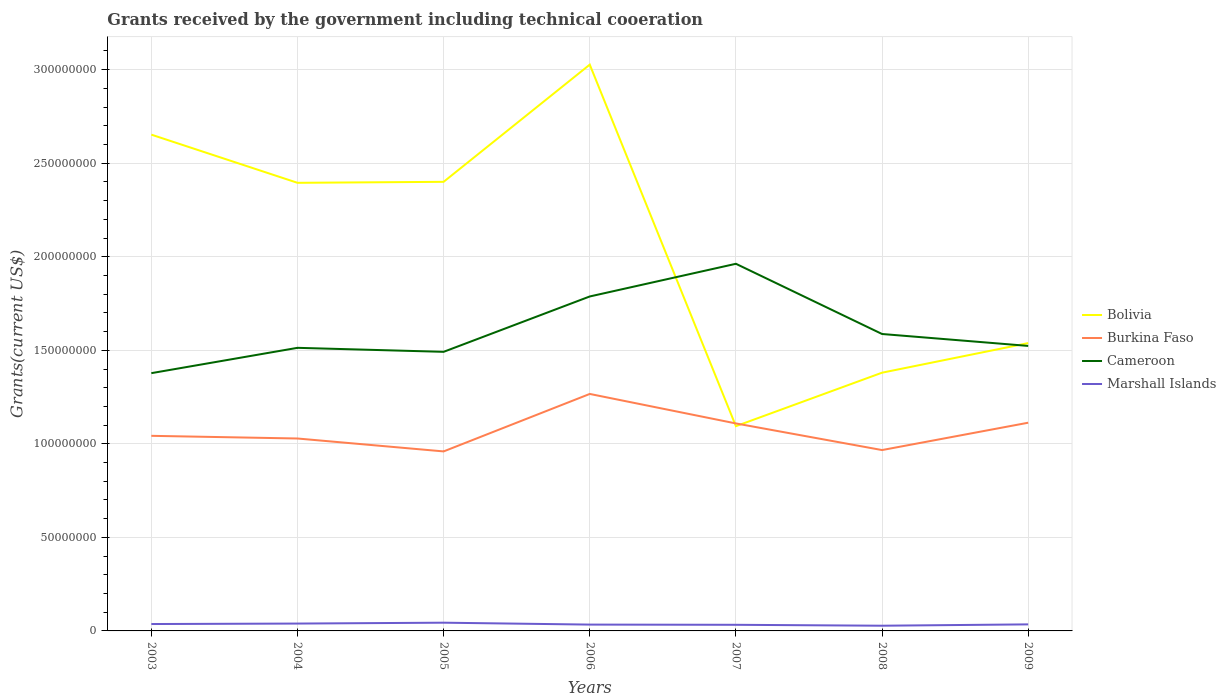How many different coloured lines are there?
Your answer should be compact. 4. Across all years, what is the maximum total grants received by the government in Cameroon?
Your response must be concise. 1.38e+08. What is the total total grants received by the government in Bolivia in the graph?
Give a very brief answer. 1.30e+08. What is the difference between the highest and the second highest total grants received by the government in Marshall Islands?
Offer a terse response. 1.62e+06. How many legend labels are there?
Make the answer very short. 4. How are the legend labels stacked?
Provide a short and direct response. Vertical. What is the title of the graph?
Your answer should be compact. Grants received by the government including technical cooeration. Does "Cayman Islands" appear as one of the legend labels in the graph?
Offer a very short reply. No. What is the label or title of the X-axis?
Your answer should be very brief. Years. What is the label or title of the Y-axis?
Your response must be concise. Grants(current US$). What is the Grants(current US$) of Bolivia in 2003?
Your answer should be compact. 2.65e+08. What is the Grants(current US$) of Burkina Faso in 2003?
Ensure brevity in your answer.  1.04e+08. What is the Grants(current US$) in Cameroon in 2003?
Offer a very short reply. 1.38e+08. What is the Grants(current US$) of Marshall Islands in 2003?
Make the answer very short. 3.68e+06. What is the Grants(current US$) of Bolivia in 2004?
Provide a short and direct response. 2.40e+08. What is the Grants(current US$) in Burkina Faso in 2004?
Offer a very short reply. 1.03e+08. What is the Grants(current US$) in Cameroon in 2004?
Your response must be concise. 1.51e+08. What is the Grants(current US$) in Marshall Islands in 2004?
Provide a succinct answer. 3.93e+06. What is the Grants(current US$) in Bolivia in 2005?
Provide a succinct answer. 2.40e+08. What is the Grants(current US$) in Burkina Faso in 2005?
Give a very brief answer. 9.60e+07. What is the Grants(current US$) of Cameroon in 2005?
Your response must be concise. 1.49e+08. What is the Grants(current US$) of Marshall Islands in 2005?
Your answer should be very brief. 4.40e+06. What is the Grants(current US$) of Bolivia in 2006?
Make the answer very short. 3.03e+08. What is the Grants(current US$) of Burkina Faso in 2006?
Offer a terse response. 1.27e+08. What is the Grants(current US$) in Cameroon in 2006?
Ensure brevity in your answer.  1.79e+08. What is the Grants(current US$) of Marshall Islands in 2006?
Your answer should be very brief. 3.38e+06. What is the Grants(current US$) in Bolivia in 2007?
Provide a succinct answer. 1.09e+08. What is the Grants(current US$) in Burkina Faso in 2007?
Provide a short and direct response. 1.11e+08. What is the Grants(current US$) in Cameroon in 2007?
Your answer should be compact. 1.96e+08. What is the Grants(current US$) in Marshall Islands in 2007?
Provide a short and direct response. 3.27e+06. What is the Grants(current US$) of Bolivia in 2008?
Keep it short and to the point. 1.38e+08. What is the Grants(current US$) in Burkina Faso in 2008?
Give a very brief answer. 9.67e+07. What is the Grants(current US$) in Cameroon in 2008?
Ensure brevity in your answer.  1.59e+08. What is the Grants(current US$) of Marshall Islands in 2008?
Provide a short and direct response. 2.78e+06. What is the Grants(current US$) in Bolivia in 2009?
Provide a succinct answer. 1.54e+08. What is the Grants(current US$) in Burkina Faso in 2009?
Offer a terse response. 1.11e+08. What is the Grants(current US$) in Cameroon in 2009?
Make the answer very short. 1.52e+08. What is the Grants(current US$) in Marshall Islands in 2009?
Your answer should be compact. 3.50e+06. Across all years, what is the maximum Grants(current US$) in Bolivia?
Provide a succinct answer. 3.03e+08. Across all years, what is the maximum Grants(current US$) in Burkina Faso?
Provide a short and direct response. 1.27e+08. Across all years, what is the maximum Grants(current US$) in Cameroon?
Make the answer very short. 1.96e+08. Across all years, what is the maximum Grants(current US$) of Marshall Islands?
Give a very brief answer. 4.40e+06. Across all years, what is the minimum Grants(current US$) in Bolivia?
Offer a terse response. 1.09e+08. Across all years, what is the minimum Grants(current US$) in Burkina Faso?
Your response must be concise. 9.60e+07. Across all years, what is the minimum Grants(current US$) of Cameroon?
Provide a succinct answer. 1.38e+08. Across all years, what is the minimum Grants(current US$) of Marshall Islands?
Your answer should be compact. 2.78e+06. What is the total Grants(current US$) of Bolivia in the graph?
Keep it short and to the point. 1.45e+09. What is the total Grants(current US$) of Burkina Faso in the graph?
Provide a short and direct response. 7.49e+08. What is the total Grants(current US$) in Cameroon in the graph?
Keep it short and to the point. 1.12e+09. What is the total Grants(current US$) in Marshall Islands in the graph?
Offer a terse response. 2.49e+07. What is the difference between the Grants(current US$) of Bolivia in 2003 and that in 2004?
Offer a very short reply. 2.58e+07. What is the difference between the Grants(current US$) in Burkina Faso in 2003 and that in 2004?
Provide a short and direct response. 1.43e+06. What is the difference between the Grants(current US$) of Cameroon in 2003 and that in 2004?
Ensure brevity in your answer.  -1.35e+07. What is the difference between the Grants(current US$) in Bolivia in 2003 and that in 2005?
Offer a very short reply. 2.52e+07. What is the difference between the Grants(current US$) in Burkina Faso in 2003 and that in 2005?
Provide a short and direct response. 8.33e+06. What is the difference between the Grants(current US$) in Cameroon in 2003 and that in 2005?
Your answer should be compact. -1.14e+07. What is the difference between the Grants(current US$) of Marshall Islands in 2003 and that in 2005?
Your answer should be very brief. -7.20e+05. What is the difference between the Grants(current US$) in Bolivia in 2003 and that in 2006?
Your response must be concise. -3.74e+07. What is the difference between the Grants(current US$) in Burkina Faso in 2003 and that in 2006?
Keep it short and to the point. -2.24e+07. What is the difference between the Grants(current US$) of Cameroon in 2003 and that in 2006?
Make the answer very short. -4.10e+07. What is the difference between the Grants(current US$) in Marshall Islands in 2003 and that in 2006?
Your answer should be very brief. 3.00e+05. What is the difference between the Grants(current US$) of Bolivia in 2003 and that in 2007?
Provide a succinct answer. 1.56e+08. What is the difference between the Grants(current US$) of Burkina Faso in 2003 and that in 2007?
Ensure brevity in your answer.  -6.62e+06. What is the difference between the Grants(current US$) of Cameroon in 2003 and that in 2007?
Provide a succinct answer. -5.85e+07. What is the difference between the Grants(current US$) of Bolivia in 2003 and that in 2008?
Provide a succinct answer. 1.27e+08. What is the difference between the Grants(current US$) in Burkina Faso in 2003 and that in 2008?
Provide a succinct answer. 7.61e+06. What is the difference between the Grants(current US$) in Cameroon in 2003 and that in 2008?
Your answer should be very brief. -2.09e+07. What is the difference between the Grants(current US$) in Marshall Islands in 2003 and that in 2008?
Make the answer very short. 9.00e+05. What is the difference between the Grants(current US$) of Bolivia in 2003 and that in 2009?
Ensure brevity in your answer.  1.11e+08. What is the difference between the Grants(current US$) in Burkina Faso in 2003 and that in 2009?
Offer a very short reply. -7.01e+06. What is the difference between the Grants(current US$) of Cameroon in 2003 and that in 2009?
Offer a terse response. -1.46e+07. What is the difference between the Grants(current US$) of Marshall Islands in 2003 and that in 2009?
Ensure brevity in your answer.  1.80e+05. What is the difference between the Grants(current US$) in Bolivia in 2004 and that in 2005?
Ensure brevity in your answer.  -5.30e+05. What is the difference between the Grants(current US$) of Burkina Faso in 2004 and that in 2005?
Ensure brevity in your answer.  6.90e+06. What is the difference between the Grants(current US$) in Cameroon in 2004 and that in 2005?
Offer a terse response. 2.14e+06. What is the difference between the Grants(current US$) of Marshall Islands in 2004 and that in 2005?
Give a very brief answer. -4.70e+05. What is the difference between the Grants(current US$) of Bolivia in 2004 and that in 2006?
Provide a short and direct response. -6.32e+07. What is the difference between the Grants(current US$) of Burkina Faso in 2004 and that in 2006?
Give a very brief answer. -2.38e+07. What is the difference between the Grants(current US$) of Cameroon in 2004 and that in 2006?
Provide a succinct answer. -2.74e+07. What is the difference between the Grants(current US$) in Marshall Islands in 2004 and that in 2006?
Make the answer very short. 5.50e+05. What is the difference between the Grants(current US$) in Bolivia in 2004 and that in 2007?
Keep it short and to the point. 1.30e+08. What is the difference between the Grants(current US$) in Burkina Faso in 2004 and that in 2007?
Keep it short and to the point. -8.05e+06. What is the difference between the Grants(current US$) of Cameroon in 2004 and that in 2007?
Offer a very short reply. -4.49e+07. What is the difference between the Grants(current US$) in Marshall Islands in 2004 and that in 2007?
Provide a short and direct response. 6.60e+05. What is the difference between the Grants(current US$) in Bolivia in 2004 and that in 2008?
Your answer should be compact. 1.01e+08. What is the difference between the Grants(current US$) of Burkina Faso in 2004 and that in 2008?
Your answer should be very brief. 6.18e+06. What is the difference between the Grants(current US$) of Cameroon in 2004 and that in 2008?
Offer a very short reply. -7.39e+06. What is the difference between the Grants(current US$) of Marshall Islands in 2004 and that in 2008?
Offer a terse response. 1.15e+06. What is the difference between the Grants(current US$) of Bolivia in 2004 and that in 2009?
Ensure brevity in your answer.  8.57e+07. What is the difference between the Grants(current US$) of Burkina Faso in 2004 and that in 2009?
Offer a terse response. -8.44e+06. What is the difference between the Grants(current US$) in Cameroon in 2004 and that in 2009?
Keep it short and to the point. -1.02e+06. What is the difference between the Grants(current US$) in Marshall Islands in 2004 and that in 2009?
Make the answer very short. 4.30e+05. What is the difference between the Grants(current US$) of Bolivia in 2005 and that in 2006?
Your answer should be very brief. -6.26e+07. What is the difference between the Grants(current US$) of Burkina Faso in 2005 and that in 2006?
Provide a succinct answer. -3.07e+07. What is the difference between the Grants(current US$) in Cameroon in 2005 and that in 2006?
Your response must be concise. -2.96e+07. What is the difference between the Grants(current US$) in Marshall Islands in 2005 and that in 2006?
Give a very brief answer. 1.02e+06. What is the difference between the Grants(current US$) of Bolivia in 2005 and that in 2007?
Ensure brevity in your answer.  1.31e+08. What is the difference between the Grants(current US$) in Burkina Faso in 2005 and that in 2007?
Give a very brief answer. -1.50e+07. What is the difference between the Grants(current US$) in Cameroon in 2005 and that in 2007?
Your answer should be very brief. -4.71e+07. What is the difference between the Grants(current US$) of Marshall Islands in 2005 and that in 2007?
Your response must be concise. 1.13e+06. What is the difference between the Grants(current US$) in Bolivia in 2005 and that in 2008?
Provide a succinct answer. 1.02e+08. What is the difference between the Grants(current US$) in Burkina Faso in 2005 and that in 2008?
Give a very brief answer. -7.20e+05. What is the difference between the Grants(current US$) in Cameroon in 2005 and that in 2008?
Offer a terse response. -9.53e+06. What is the difference between the Grants(current US$) in Marshall Islands in 2005 and that in 2008?
Make the answer very short. 1.62e+06. What is the difference between the Grants(current US$) of Bolivia in 2005 and that in 2009?
Keep it short and to the point. 8.62e+07. What is the difference between the Grants(current US$) in Burkina Faso in 2005 and that in 2009?
Your answer should be compact. -1.53e+07. What is the difference between the Grants(current US$) of Cameroon in 2005 and that in 2009?
Offer a very short reply. -3.16e+06. What is the difference between the Grants(current US$) of Bolivia in 2006 and that in 2007?
Provide a short and direct response. 1.93e+08. What is the difference between the Grants(current US$) of Burkina Faso in 2006 and that in 2007?
Provide a succinct answer. 1.58e+07. What is the difference between the Grants(current US$) of Cameroon in 2006 and that in 2007?
Keep it short and to the point. -1.75e+07. What is the difference between the Grants(current US$) of Marshall Islands in 2006 and that in 2007?
Offer a very short reply. 1.10e+05. What is the difference between the Grants(current US$) of Bolivia in 2006 and that in 2008?
Your response must be concise. 1.65e+08. What is the difference between the Grants(current US$) of Burkina Faso in 2006 and that in 2008?
Your answer should be very brief. 3.00e+07. What is the difference between the Grants(current US$) of Cameroon in 2006 and that in 2008?
Give a very brief answer. 2.01e+07. What is the difference between the Grants(current US$) in Bolivia in 2006 and that in 2009?
Your answer should be very brief. 1.49e+08. What is the difference between the Grants(current US$) of Burkina Faso in 2006 and that in 2009?
Provide a succinct answer. 1.54e+07. What is the difference between the Grants(current US$) of Cameroon in 2006 and that in 2009?
Keep it short and to the point. 2.64e+07. What is the difference between the Grants(current US$) of Bolivia in 2007 and that in 2008?
Ensure brevity in your answer.  -2.86e+07. What is the difference between the Grants(current US$) in Burkina Faso in 2007 and that in 2008?
Provide a succinct answer. 1.42e+07. What is the difference between the Grants(current US$) of Cameroon in 2007 and that in 2008?
Provide a succinct answer. 3.75e+07. What is the difference between the Grants(current US$) in Bolivia in 2007 and that in 2009?
Keep it short and to the point. -4.44e+07. What is the difference between the Grants(current US$) of Burkina Faso in 2007 and that in 2009?
Keep it short and to the point. -3.90e+05. What is the difference between the Grants(current US$) of Cameroon in 2007 and that in 2009?
Provide a short and direct response. 4.39e+07. What is the difference between the Grants(current US$) in Bolivia in 2008 and that in 2009?
Offer a very short reply. -1.58e+07. What is the difference between the Grants(current US$) of Burkina Faso in 2008 and that in 2009?
Make the answer very short. -1.46e+07. What is the difference between the Grants(current US$) of Cameroon in 2008 and that in 2009?
Your answer should be compact. 6.37e+06. What is the difference between the Grants(current US$) in Marshall Islands in 2008 and that in 2009?
Keep it short and to the point. -7.20e+05. What is the difference between the Grants(current US$) of Bolivia in 2003 and the Grants(current US$) of Burkina Faso in 2004?
Make the answer very short. 1.62e+08. What is the difference between the Grants(current US$) in Bolivia in 2003 and the Grants(current US$) in Cameroon in 2004?
Make the answer very short. 1.14e+08. What is the difference between the Grants(current US$) of Bolivia in 2003 and the Grants(current US$) of Marshall Islands in 2004?
Your response must be concise. 2.61e+08. What is the difference between the Grants(current US$) of Burkina Faso in 2003 and the Grants(current US$) of Cameroon in 2004?
Give a very brief answer. -4.70e+07. What is the difference between the Grants(current US$) in Burkina Faso in 2003 and the Grants(current US$) in Marshall Islands in 2004?
Provide a short and direct response. 1.00e+08. What is the difference between the Grants(current US$) of Cameroon in 2003 and the Grants(current US$) of Marshall Islands in 2004?
Your response must be concise. 1.34e+08. What is the difference between the Grants(current US$) of Bolivia in 2003 and the Grants(current US$) of Burkina Faso in 2005?
Keep it short and to the point. 1.69e+08. What is the difference between the Grants(current US$) in Bolivia in 2003 and the Grants(current US$) in Cameroon in 2005?
Keep it short and to the point. 1.16e+08. What is the difference between the Grants(current US$) in Bolivia in 2003 and the Grants(current US$) in Marshall Islands in 2005?
Keep it short and to the point. 2.61e+08. What is the difference between the Grants(current US$) of Burkina Faso in 2003 and the Grants(current US$) of Cameroon in 2005?
Give a very brief answer. -4.49e+07. What is the difference between the Grants(current US$) in Burkina Faso in 2003 and the Grants(current US$) in Marshall Islands in 2005?
Provide a short and direct response. 9.99e+07. What is the difference between the Grants(current US$) of Cameroon in 2003 and the Grants(current US$) of Marshall Islands in 2005?
Give a very brief answer. 1.33e+08. What is the difference between the Grants(current US$) of Bolivia in 2003 and the Grants(current US$) of Burkina Faso in 2006?
Keep it short and to the point. 1.39e+08. What is the difference between the Grants(current US$) in Bolivia in 2003 and the Grants(current US$) in Cameroon in 2006?
Give a very brief answer. 8.65e+07. What is the difference between the Grants(current US$) of Bolivia in 2003 and the Grants(current US$) of Marshall Islands in 2006?
Make the answer very short. 2.62e+08. What is the difference between the Grants(current US$) of Burkina Faso in 2003 and the Grants(current US$) of Cameroon in 2006?
Make the answer very short. -7.45e+07. What is the difference between the Grants(current US$) in Burkina Faso in 2003 and the Grants(current US$) in Marshall Islands in 2006?
Your answer should be very brief. 1.01e+08. What is the difference between the Grants(current US$) of Cameroon in 2003 and the Grants(current US$) of Marshall Islands in 2006?
Offer a terse response. 1.34e+08. What is the difference between the Grants(current US$) in Bolivia in 2003 and the Grants(current US$) in Burkina Faso in 2007?
Provide a short and direct response. 1.54e+08. What is the difference between the Grants(current US$) of Bolivia in 2003 and the Grants(current US$) of Cameroon in 2007?
Provide a succinct answer. 6.90e+07. What is the difference between the Grants(current US$) in Bolivia in 2003 and the Grants(current US$) in Marshall Islands in 2007?
Keep it short and to the point. 2.62e+08. What is the difference between the Grants(current US$) in Burkina Faso in 2003 and the Grants(current US$) in Cameroon in 2007?
Offer a very short reply. -9.20e+07. What is the difference between the Grants(current US$) of Burkina Faso in 2003 and the Grants(current US$) of Marshall Islands in 2007?
Your response must be concise. 1.01e+08. What is the difference between the Grants(current US$) in Cameroon in 2003 and the Grants(current US$) in Marshall Islands in 2007?
Your response must be concise. 1.35e+08. What is the difference between the Grants(current US$) of Bolivia in 2003 and the Grants(current US$) of Burkina Faso in 2008?
Make the answer very short. 1.69e+08. What is the difference between the Grants(current US$) in Bolivia in 2003 and the Grants(current US$) in Cameroon in 2008?
Keep it short and to the point. 1.07e+08. What is the difference between the Grants(current US$) in Bolivia in 2003 and the Grants(current US$) in Marshall Islands in 2008?
Give a very brief answer. 2.62e+08. What is the difference between the Grants(current US$) in Burkina Faso in 2003 and the Grants(current US$) in Cameroon in 2008?
Your answer should be compact. -5.44e+07. What is the difference between the Grants(current US$) in Burkina Faso in 2003 and the Grants(current US$) in Marshall Islands in 2008?
Make the answer very short. 1.02e+08. What is the difference between the Grants(current US$) of Cameroon in 2003 and the Grants(current US$) of Marshall Islands in 2008?
Your answer should be compact. 1.35e+08. What is the difference between the Grants(current US$) of Bolivia in 2003 and the Grants(current US$) of Burkina Faso in 2009?
Offer a terse response. 1.54e+08. What is the difference between the Grants(current US$) in Bolivia in 2003 and the Grants(current US$) in Cameroon in 2009?
Offer a very short reply. 1.13e+08. What is the difference between the Grants(current US$) of Bolivia in 2003 and the Grants(current US$) of Marshall Islands in 2009?
Your response must be concise. 2.62e+08. What is the difference between the Grants(current US$) in Burkina Faso in 2003 and the Grants(current US$) in Cameroon in 2009?
Provide a short and direct response. -4.81e+07. What is the difference between the Grants(current US$) of Burkina Faso in 2003 and the Grants(current US$) of Marshall Islands in 2009?
Ensure brevity in your answer.  1.01e+08. What is the difference between the Grants(current US$) of Cameroon in 2003 and the Grants(current US$) of Marshall Islands in 2009?
Offer a terse response. 1.34e+08. What is the difference between the Grants(current US$) of Bolivia in 2004 and the Grants(current US$) of Burkina Faso in 2005?
Your response must be concise. 1.44e+08. What is the difference between the Grants(current US$) in Bolivia in 2004 and the Grants(current US$) in Cameroon in 2005?
Give a very brief answer. 9.03e+07. What is the difference between the Grants(current US$) in Bolivia in 2004 and the Grants(current US$) in Marshall Islands in 2005?
Your response must be concise. 2.35e+08. What is the difference between the Grants(current US$) of Burkina Faso in 2004 and the Grants(current US$) of Cameroon in 2005?
Keep it short and to the point. -4.63e+07. What is the difference between the Grants(current US$) of Burkina Faso in 2004 and the Grants(current US$) of Marshall Islands in 2005?
Give a very brief answer. 9.84e+07. What is the difference between the Grants(current US$) in Cameroon in 2004 and the Grants(current US$) in Marshall Islands in 2005?
Offer a terse response. 1.47e+08. What is the difference between the Grants(current US$) in Bolivia in 2004 and the Grants(current US$) in Burkina Faso in 2006?
Your answer should be compact. 1.13e+08. What is the difference between the Grants(current US$) in Bolivia in 2004 and the Grants(current US$) in Cameroon in 2006?
Give a very brief answer. 6.08e+07. What is the difference between the Grants(current US$) in Bolivia in 2004 and the Grants(current US$) in Marshall Islands in 2006?
Provide a succinct answer. 2.36e+08. What is the difference between the Grants(current US$) of Burkina Faso in 2004 and the Grants(current US$) of Cameroon in 2006?
Keep it short and to the point. -7.59e+07. What is the difference between the Grants(current US$) of Burkina Faso in 2004 and the Grants(current US$) of Marshall Islands in 2006?
Give a very brief answer. 9.95e+07. What is the difference between the Grants(current US$) of Cameroon in 2004 and the Grants(current US$) of Marshall Islands in 2006?
Keep it short and to the point. 1.48e+08. What is the difference between the Grants(current US$) in Bolivia in 2004 and the Grants(current US$) in Burkina Faso in 2007?
Offer a terse response. 1.29e+08. What is the difference between the Grants(current US$) in Bolivia in 2004 and the Grants(current US$) in Cameroon in 2007?
Your response must be concise. 4.33e+07. What is the difference between the Grants(current US$) in Bolivia in 2004 and the Grants(current US$) in Marshall Islands in 2007?
Offer a terse response. 2.36e+08. What is the difference between the Grants(current US$) of Burkina Faso in 2004 and the Grants(current US$) of Cameroon in 2007?
Offer a very short reply. -9.34e+07. What is the difference between the Grants(current US$) in Burkina Faso in 2004 and the Grants(current US$) in Marshall Islands in 2007?
Your response must be concise. 9.96e+07. What is the difference between the Grants(current US$) of Cameroon in 2004 and the Grants(current US$) of Marshall Islands in 2007?
Make the answer very short. 1.48e+08. What is the difference between the Grants(current US$) in Bolivia in 2004 and the Grants(current US$) in Burkina Faso in 2008?
Offer a terse response. 1.43e+08. What is the difference between the Grants(current US$) in Bolivia in 2004 and the Grants(current US$) in Cameroon in 2008?
Provide a short and direct response. 8.08e+07. What is the difference between the Grants(current US$) in Bolivia in 2004 and the Grants(current US$) in Marshall Islands in 2008?
Your answer should be compact. 2.37e+08. What is the difference between the Grants(current US$) in Burkina Faso in 2004 and the Grants(current US$) in Cameroon in 2008?
Make the answer very short. -5.59e+07. What is the difference between the Grants(current US$) of Burkina Faso in 2004 and the Grants(current US$) of Marshall Islands in 2008?
Your answer should be very brief. 1.00e+08. What is the difference between the Grants(current US$) in Cameroon in 2004 and the Grants(current US$) in Marshall Islands in 2008?
Give a very brief answer. 1.49e+08. What is the difference between the Grants(current US$) in Bolivia in 2004 and the Grants(current US$) in Burkina Faso in 2009?
Keep it short and to the point. 1.28e+08. What is the difference between the Grants(current US$) of Bolivia in 2004 and the Grants(current US$) of Cameroon in 2009?
Make the answer very short. 8.72e+07. What is the difference between the Grants(current US$) of Bolivia in 2004 and the Grants(current US$) of Marshall Islands in 2009?
Give a very brief answer. 2.36e+08. What is the difference between the Grants(current US$) of Burkina Faso in 2004 and the Grants(current US$) of Cameroon in 2009?
Offer a very short reply. -4.95e+07. What is the difference between the Grants(current US$) of Burkina Faso in 2004 and the Grants(current US$) of Marshall Islands in 2009?
Give a very brief answer. 9.94e+07. What is the difference between the Grants(current US$) of Cameroon in 2004 and the Grants(current US$) of Marshall Islands in 2009?
Offer a very short reply. 1.48e+08. What is the difference between the Grants(current US$) in Bolivia in 2005 and the Grants(current US$) in Burkina Faso in 2006?
Give a very brief answer. 1.13e+08. What is the difference between the Grants(current US$) in Bolivia in 2005 and the Grants(current US$) in Cameroon in 2006?
Keep it short and to the point. 6.13e+07. What is the difference between the Grants(current US$) in Bolivia in 2005 and the Grants(current US$) in Marshall Islands in 2006?
Your answer should be very brief. 2.37e+08. What is the difference between the Grants(current US$) of Burkina Faso in 2005 and the Grants(current US$) of Cameroon in 2006?
Provide a short and direct response. -8.28e+07. What is the difference between the Grants(current US$) of Burkina Faso in 2005 and the Grants(current US$) of Marshall Islands in 2006?
Your answer should be compact. 9.26e+07. What is the difference between the Grants(current US$) in Cameroon in 2005 and the Grants(current US$) in Marshall Islands in 2006?
Your response must be concise. 1.46e+08. What is the difference between the Grants(current US$) in Bolivia in 2005 and the Grants(current US$) in Burkina Faso in 2007?
Offer a very short reply. 1.29e+08. What is the difference between the Grants(current US$) in Bolivia in 2005 and the Grants(current US$) in Cameroon in 2007?
Keep it short and to the point. 4.38e+07. What is the difference between the Grants(current US$) in Bolivia in 2005 and the Grants(current US$) in Marshall Islands in 2007?
Your response must be concise. 2.37e+08. What is the difference between the Grants(current US$) in Burkina Faso in 2005 and the Grants(current US$) in Cameroon in 2007?
Keep it short and to the point. -1.00e+08. What is the difference between the Grants(current US$) of Burkina Faso in 2005 and the Grants(current US$) of Marshall Islands in 2007?
Offer a very short reply. 9.27e+07. What is the difference between the Grants(current US$) of Cameroon in 2005 and the Grants(current US$) of Marshall Islands in 2007?
Make the answer very short. 1.46e+08. What is the difference between the Grants(current US$) in Bolivia in 2005 and the Grants(current US$) in Burkina Faso in 2008?
Make the answer very short. 1.43e+08. What is the difference between the Grants(current US$) of Bolivia in 2005 and the Grants(current US$) of Cameroon in 2008?
Ensure brevity in your answer.  8.13e+07. What is the difference between the Grants(current US$) in Bolivia in 2005 and the Grants(current US$) in Marshall Islands in 2008?
Offer a very short reply. 2.37e+08. What is the difference between the Grants(current US$) of Burkina Faso in 2005 and the Grants(current US$) of Cameroon in 2008?
Your answer should be compact. -6.28e+07. What is the difference between the Grants(current US$) of Burkina Faso in 2005 and the Grants(current US$) of Marshall Islands in 2008?
Give a very brief answer. 9.32e+07. What is the difference between the Grants(current US$) of Cameroon in 2005 and the Grants(current US$) of Marshall Islands in 2008?
Provide a succinct answer. 1.46e+08. What is the difference between the Grants(current US$) in Bolivia in 2005 and the Grants(current US$) in Burkina Faso in 2009?
Offer a terse response. 1.29e+08. What is the difference between the Grants(current US$) of Bolivia in 2005 and the Grants(current US$) of Cameroon in 2009?
Ensure brevity in your answer.  8.77e+07. What is the difference between the Grants(current US$) in Bolivia in 2005 and the Grants(current US$) in Marshall Islands in 2009?
Provide a succinct answer. 2.37e+08. What is the difference between the Grants(current US$) in Burkina Faso in 2005 and the Grants(current US$) in Cameroon in 2009?
Your response must be concise. -5.64e+07. What is the difference between the Grants(current US$) in Burkina Faso in 2005 and the Grants(current US$) in Marshall Islands in 2009?
Ensure brevity in your answer.  9.24e+07. What is the difference between the Grants(current US$) of Cameroon in 2005 and the Grants(current US$) of Marshall Islands in 2009?
Provide a short and direct response. 1.46e+08. What is the difference between the Grants(current US$) of Bolivia in 2006 and the Grants(current US$) of Burkina Faso in 2007?
Give a very brief answer. 1.92e+08. What is the difference between the Grants(current US$) in Bolivia in 2006 and the Grants(current US$) in Cameroon in 2007?
Your answer should be very brief. 1.06e+08. What is the difference between the Grants(current US$) in Bolivia in 2006 and the Grants(current US$) in Marshall Islands in 2007?
Give a very brief answer. 2.99e+08. What is the difference between the Grants(current US$) of Burkina Faso in 2006 and the Grants(current US$) of Cameroon in 2007?
Provide a succinct answer. -6.96e+07. What is the difference between the Grants(current US$) in Burkina Faso in 2006 and the Grants(current US$) in Marshall Islands in 2007?
Make the answer very short. 1.23e+08. What is the difference between the Grants(current US$) of Cameroon in 2006 and the Grants(current US$) of Marshall Islands in 2007?
Offer a very short reply. 1.76e+08. What is the difference between the Grants(current US$) in Bolivia in 2006 and the Grants(current US$) in Burkina Faso in 2008?
Provide a succinct answer. 2.06e+08. What is the difference between the Grants(current US$) of Bolivia in 2006 and the Grants(current US$) of Cameroon in 2008?
Offer a terse response. 1.44e+08. What is the difference between the Grants(current US$) of Bolivia in 2006 and the Grants(current US$) of Marshall Islands in 2008?
Ensure brevity in your answer.  3.00e+08. What is the difference between the Grants(current US$) in Burkina Faso in 2006 and the Grants(current US$) in Cameroon in 2008?
Your answer should be very brief. -3.20e+07. What is the difference between the Grants(current US$) of Burkina Faso in 2006 and the Grants(current US$) of Marshall Islands in 2008?
Your response must be concise. 1.24e+08. What is the difference between the Grants(current US$) in Cameroon in 2006 and the Grants(current US$) in Marshall Islands in 2008?
Ensure brevity in your answer.  1.76e+08. What is the difference between the Grants(current US$) of Bolivia in 2006 and the Grants(current US$) of Burkina Faso in 2009?
Your response must be concise. 1.91e+08. What is the difference between the Grants(current US$) of Bolivia in 2006 and the Grants(current US$) of Cameroon in 2009?
Offer a very short reply. 1.50e+08. What is the difference between the Grants(current US$) in Bolivia in 2006 and the Grants(current US$) in Marshall Islands in 2009?
Your answer should be very brief. 2.99e+08. What is the difference between the Grants(current US$) of Burkina Faso in 2006 and the Grants(current US$) of Cameroon in 2009?
Keep it short and to the point. -2.57e+07. What is the difference between the Grants(current US$) in Burkina Faso in 2006 and the Grants(current US$) in Marshall Islands in 2009?
Give a very brief answer. 1.23e+08. What is the difference between the Grants(current US$) of Cameroon in 2006 and the Grants(current US$) of Marshall Islands in 2009?
Give a very brief answer. 1.75e+08. What is the difference between the Grants(current US$) of Bolivia in 2007 and the Grants(current US$) of Burkina Faso in 2008?
Make the answer very short. 1.28e+07. What is the difference between the Grants(current US$) in Bolivia in 2007 and the Grants(current US$) in Cameroon in 2008?
Provide a short and direct response. -4.93e+07. What is the difference between the Grants(current US$) of Bolivia in 2007 and the Grants(current US$) of Marshall Islands in 2008?
Offer a very short reply. 1.07e+08. What is the difference between the Grants(current US$) in Burkina Faso in 2007 and the Grants(current US$) in Cameroon in 2008?
Your answer should be very brief. -4.78e+07. What is the difference between the Grants(current US$) of Burkina Faso in 2007 and the Grants(current US$) of Marshall Islands in 2008?
Ensure brevity in your answer.  1.08e+08. What is the difference between the Grants(current US$) in Cameroon in 2007 and the Grants(current US$) in Marshall Islands in 2008?
Your response must be concise. 1.93e+08. What is the difference between the Grants(current US$) in Bolivia in 2007 and the Grants(current US$) in Burkina Faso in 2009?
Provide a succinct answer. -1.85e+06. What is the difference between the Grants(current US$) of Bolivia in 2007 and the Grants(current US$) of Cameroon in 2009?
Offer a terse response. -4.29e+07. What is the difference between the Grants(current US$) of Bolivia in 2007 and the Grants(current US$) of Marshall Islands in 2009?
Give a very brief answer. 1.06e+08. What is the difference between the Grants(current US$) of Burkina Faso in 2007 and the Grants(current US$) of Cameroon in 2009?
Offer a very short reply. -4.14e+07. What is the difference between the Grants(current US$) of Burkina Faso in 2007 and the Grants(current US$) of Marshall Islands in 2009?
Offer a terse response. 1.07e+08. What is the difference between the Grants(current US$) of Cameroon in 2007 and the Grants(current US$) of Marshall Islands in 2009?
Your response must be concise. 1.93e+08. What is the difference between the Grants(current US$) of Bolivia in 2008 and the Grants(current US$) of Burkina Faso in 2009?
Make the answer very short. 2.67e+07. What is the difference between the Grants(current US$) in Bolivia in 2008 and the Grants(current US$) in Cameroon in 2009?
Keep it short and to the point. -1.43e+07. What is the difference between the Grants(current US$) in Bolivia in 2008 and the Grants(current US$) in Marshall Islands in 2009?
Ensure brevity in your answer.  1.35e+08. What is the difference between the Grants(current US$) of Burkina Faso in 2008 and the Grants(current US$) of Cameroon in 2009?
Provide a succinct answer. -5.57e+07. What is the difference between the Grants(current US$) of Burkina Faso in 2008 and the Grants(current US$) of Marshall Islands in 2009?
Offer a very short reply. 9.32e+07. What is the difference between the Grants(current US$) of Cameroon in 2008 and the Grants(current US$) of Marshall Islands in 2009?
Give a very brief answer. 1.55e+08. What is the average Grants(current US$) of Bolivia per year?
Your answer should be very brief. 2.07e+08. What is the average Grants(current US$) of Burkina Faso per year?
Offer a very short reply. 1.07e+08. What is the average Grants(current US$) in Cameroon per year?
Make the answer very short. 1.61e+08. What is the average Grants(current US$) in Marshall Islands per year?
Your response must be concise. 3.56e+06. In the year 2003, what is the difference between the Grants(current US$) in Bolivia and Grants(current US$) in Burkina Faso?
Provide a succinct answer. 1.61e+08. In the year 2003, what is the difference between the Grants(current US$) in Bolivia and Grants(current US$) in Cameroon?
Offer a terse response. 1.27e+08. In the year 2003, what is the difference between the Grants(current US$) in Bolivia and Grants(current US$) in Marshall Islands?
Your answer should be very brief. 2.62e+08. In the year 2003, what is the difference between the Grants(current US$) of Burkina Faso and Grants(current US$) of Cameroon?
Keep it short and to the point. -3.35e+07. In the year 2003, what is the difference between the Grants(current US$) of Burkina Faso and Grants(current US$) of Marshall Islands?
Keep it short and to the point. 1.01e+08. In the year 2003, what is the difference between the Grants(current US$) of Cameroon and Grants(current US$) of Marshall Islands?
Offer a very short reply. 1.34e+08. In the year 2004, what is the difference between the Grants(current US$) of Bolivia and Grants(current US$) of Burkina Faso?
Ensure brevity in your answer.  1.37e+08. In the year 2004, what is the difference between the Grants(current US$) of Bolivia and Grants(current US$) of Cameroon?
Provide a succinct answer. 8.82e+07. In the year 2004, what is the difference between the Grants(current US$) in Bolivia and Grants(current US$) in Marshall Islands?
Provide a succinct answer. 2.36e+08. In the year 2004, what is the difference between the Grants(current US$) in Burkina Faso and Grants(current US$) in Cameroon?
Provide a short and direct response. -4.85e+07. In the year 2004, what is the difference between the Grants(current US$) of Burkina Faso and Grants(current US$) of Marshall Islands?
Your answer should be compact. 9.89e+07. In the year 2004, what is the difference between the Grants(current US$) of Cameroon and Grants(current US$) of Marshall Islands?
Make the answer very short. 1.47e+08. In the year 2005, what is the difference between the Grants(current US$) of Bolivia and Grants(current US$) of Burkina Faso?
Offer a terse response. 1.44e+08. In the year 2005, what is the difference between the Grants(current US$) in Bolivia and Grants(current US$) in Cameroon?
Provide a succinct answer. 9.09e+07. In the year 2005, what is the difference between the Grants(current US$) of Bolivia and Grants(current US$) of Marshall Islands?
Make the answer very short. 2.36e+08. In the year 2005, what is the difference between the Grants(current US$) of Burkina Faso and Grants(current US$) of Cameroon?
Offer a terse response. -5.32e+07. In the year 2005, what is the difference between the Grants(current US$) in Burkina Faso and Grants(current US$) in Marshall Islands?
Your answer should be compact. 9.16e+07. In the year 2005, what is the difference between the Grants(current US$) of Cameroon and Grants(current US$) of Marshall Islands?
Offer a very short reply. 1.45e+08. In the year 2006, what is the difference between the Grants(current US$) of Bolivia and Grants(current US$) of Burkina Faso?
Ensure brevity in your answer.  1.76e+08. In the year 2006, what is the difference between the Grants(current US$) of Bolivia and Grants(current US$) of Cameroon?
Your answer should be compact. 1.24e+08. In the year 2006, what is the difference between the Grants(current US$) in Bolivia and Grants(current US$) in Marshall Islands?
Give a very brief answer. 2.99e+08. In the year 2006, what is the difference between the Grants(current US$) of Burkina Faso and Grants(current US$) of Cameroon?
Your response must be concise. -5.21e+07. In the year 2006, what is the difference between the Grants(current US$) of Burkina Faso and Grants(current US$) of Marshall Islands?
Make the answer very short. 1.23e+08. In the year 2006, what is the difference between the Grants(current US$) of Cameroon and Grants(current US$) of Marshall Islands?
Offer a very short reply. 1.75e+08. In the year 2007, what is the difference between the Grants(current US$) of Bolivia and Grants(current US$) of Burkina Faso?
Keep it short and to the point. -1.46e+06. In the year 2007, what is the difference between the Grants(current US$) of Bolivia and Grants(current US$) of Cameroon?
Give a very brief answer. -8.68e+07. In the year 2007, what is the difference between the Grants(current US$) in Bolivia and Grants(current US$) in Marshall Islands?
Make the answer very short. 1.06e+08. In the year 2007, what is the difference between the Grants(current US$) in Burkina Faso and Grants(current US$) in Cameroon?
Keep it short and to the point. -8.53e+07. In the year 2007, what is the difference between the Grants(current US$) in Burkina Faso and Grants(current US$) in Marshall Islands?
Your response must be concise. 1.08e+08. In the year 2007, what is the difference between the Grants(current US$) in Cameroon and Grants(current US$) in Marshall Islands?
Offer a terse response. 1.93e+08. In the year 2008, what is the difference between the Grants(current US$) of Bolivia and Grants(current US$) of Burkina Faso?
Make the answer very short. 4.14e+07. In the year 2008, what is the difference between the Grants(current US$) in Bolivia and Grants(current US$) in Cameroon?
Provide a short and direct response. -2.07e+07. In the year 2008, what is the difference between the Grants(current US$) in Bolivia and Grants(current US$) in Marshall Islands?
Keep it short and to the point. 1.35e+08. In the year 2008, what is the difference between the Grants(current US$) in Burkina Faso and Grants(current US$) in Cameroon?
Your response must be concise. -6.20e+07. In the year 2008, what is the difference between the Grants(current US$) of Burkina Faso and Grants(current US$) of Marshall Islands?
Provide a succinct answer. 9.39e+07. In the year 2008, what is the difference between the Grants(current US$) of Cameroon and Grants(current US$) of Marshall Islands?
Your answer should be very brief. 1.56e+08. In the year 2009, what is the difference between the Grants(current US$) of Bolivia and Grants(current US$) of Burkina Faso?
Offer a very short reply. 4.26e+07. In the year 2009, what is the difference between the Grants(current US$) of Bolivia and Grants(current US$) of Cameroon?
Your response must be concise. 1.50e+06. In the year 2009, what is the difference between the Grants(current US$) of Bolivia and Grants(current US$) of Marshall Islands?
Give a very brief answer. 1.50e+08. In the year 2009, what is the difference between the Grants(current US$) in Burkina Faso and Grants(current US$) in Cameroon?
Offer a terse response. -4.10e+07. In the year 2009, what is the difference between the Grants(current US$) in Burkina Faso and Grants(current US$) in Marshall Islands?
Ensure brevity in your answer.  1.08e+08. In the year 2009, what is the difference between the Grants(current US$) of Cameroon and Grants(current US$) of Marshall Islands?
Provide a short and direct response. 1.49e+08. What is the ratio of the Grants(current US$) of Bolivia in 2003 to that in 2004?
Ensure brevity in your answer.  1.11. What is the ratio of the Grants(current US$) in Burkina Faso in 2003 to that in 2004?
Make the answer very short. 1.01. What is the ratio of the Grants(current US$) of Cameroon in 2003 to that in 2004?
Your answer should be compact. 0.91. What is the ratio of the Grants(current US$) in Marshall Islands in 2003 to that in 2004?
Provide a succinct answer. 0.94. What is the ratio of the Grants(current US$) in Bolivia in 2003 to that in 2005?
Keep it short and to the point. 1.11. What is the ratio of the Grants(current US$) of Burkina Faso in 2003 to that in 2005?
Give a very brief answer. 1.09. What is the ratio of the Grants(current US$) of Cameroon in 2003 to that in 2005?
Make the answer very short. 0.92. What is the ratio of the Grants(current US$) in Marshall Islands in 2003 to that in 2005?
Offer a terse response. 0.84. What is the ratio of the Grants(current US$) of Bolivia in 2003 to that in 2006?
Provide a short and direct response. 0.88. What is the ratio of the Grants(current US$) in Burkina Faso in 2003 to that in 2006?
Provide a succinct answer. 0.82. What is the ratio of the Grants(current US$) in Cameroon in 2003 to that in 2006?
Give a very brief answer. 0.77. What is the ratio of the Grants(current US$) of Marshall Islands in 2003 to that in 2006?
Provide a short and direct response. 1.09. What is the ratio of the Grants(current US$) in Bolivia in 2003 to that in 2007?
Your answer should be very brief. 2.42. What is the ratio of the Grants(current US$) in Burkina Faso in 2003 to that in 2007?
Your response must be concise. 0.94. What is the ratio of the Grants(current US$) of Cameroon in 2003 to that in 2007?
Ensure brevity in your answer.  0.7. What is the ratio of the Grants(current US$) in Marshall Islands in 2003 to that in 2007?
Offer a very short reply. 1.13. What is the ratio of the Grants(current US$) of Bolivia in 2003 to that in 2008?
Provide a succinct answer. 1.92. What is the ratio of the Grants(current US$) in Burkina Faso in 2003 to that in 2008?
Keep it short and to the point. 1.08. What is the ratio of the Grants(current US$) of Cameroon in 2003 to that in 2008?
Your response must be concise. 0.87. What is the ratio of the Grants(current US$) in Marshall Islands in 2003 to that in 2008?
Your answer should be compact. 1.32. What is the ratio of the Grants(current US$) of Bolivia in 2003 to that in 2009?
Your answer should be very brief. 1.72. What is the ratio of the Grants(current US$) of Burkina Faso in 2003 to that in 2009?
Offer a very short reply. 0.94. What is the ratio of the Grants(current US$) of Cameroon in 2003 to that in 2009?
Keep it short and to the point. 0.9. What is the ratio of the Grants(current US$) of Marshall Islands in 2003 to that in 2009?
Give a very brief answer. 1.05. What is the ratio of the Grants(current US$) in Burkina Faso in 2004 to that in 2005?
Ensure brevity in your answer.  1.07. What is the ratio of the Grants(current US$) of Cameroon in 2004 to that in 2005?
Your answer should be very brief. 1.01. What is the ratio of the Grants(current US$) in Marshall Islands in 2004 to that in 2005?
Keep it short and to the point. 0.89. What is the ratio of the Grants(current US$) of Bolivia in 2004 to that in 2006?
Provide a succinct answer. 0.79. What is the ratio of the Grants(current US$) of Burkina Faso in 2004 to that in 2006?
Offer a terse response. 0.81. What is the ratio of the Grants(current US$) of Cameroon in 2004 to that in 2006?
Your answer should be very brief. 0.85. What is the ratio of the Grants(current US$) in Marshall Islands in 2004 to that in 2006?
Offer a terse response. 1.16. What is the ratio of the Grants(current US$) of Bolivia in 2004 to that in 2007?
Offer a terse response. 2.19. What is the ratio of the Grants(current US$) in Burkina Faso in 2004 to that in 2007?
Make the answer very short. 0.93. What is the ratio of the Grants(current US$) of Cameroon in 2004 to that in 2007?
Your answer should be compact. 0.77. What is the ratio of the Grants(current US$) of Marshall Islands in 2004 to that in 2007?
Give a very brief answer. 1.2. What is the ratio of the Grants(current US$) in Bolivia in 2004 to that in 2008?
Your answer should be very brief. 1.74. What is the ratio of the Grants(current US$) in Burkina Faso in 2004 to that in 2008?
Provide a short and direct response. 1.06. What is the ratio of the Grants(current US$) in Cameroon in 2004 to that in 2008?
Provide a succinct answer. 0.95. What is the ratio of the Grants(current US$) in Marshall Islands in 2004 to that in 2008?
Provide a succinct answer. 1.41. What is the ratio of the Grants(current US$) of Bolivia in 2004 to that in 2009?
Offer a very short reply. 1.56. What is the ratio of the Grants(current US$) in Burkina Faso in 2004 to that in 2009?
Provide a succinct answer. 0.92. What is the ratio of the Grants(current US$) in Cameroon in 2004 to that in 2009?
Your response must be concise. 0.99. What is the ratio of the Grants(current US$) in Marshall Islands in 2004 to that in 2009?
Ensure brevity in your answer.  1.12. What is the ratio of the Grants(current US$) of Bolivia in 2005 to that in 2006?
Provide a succinct answer. 0.79. What is the ratio of the Grants(current US$) in Burkina Faso in 2005 to that in 2006?
Provide a short and direct response. 0.76. What is the ratio of the Grants(current US$) of Cameroon in 2005 to that in 2006?
Offer a terse response. 0.83. What is the ratio of the Grants(current US$) in Marshall Islands in 2005 to that in 2006?
Keep it short and to the point. 1.3. What is the ratio of the Grants(current US$) in Bolivia in 2005 to that in 2007?
Ensure brevity in your answer.  2.19. What is the ratio of the Grants(current US$) of Burkina Faso in 2005 to that in 2007?
Give a very brief answer. 0.87. What is the ratio of the Grants(current US$) of Cameroon in 2005 to that in 2007?
Make the answer very short. 0.76. What is the ratio of the Grants(current US$) in Marshall Islands in 2005 to that in 2007?
Provide a short and direct response. 1.35. What is the ratio of the Grants(current US$) in Bolivia in 2005 to that in 2008?
Your response must be concise. 1.74. What is the ratio of the Grants(current US$) in Marshall Islands in 2005 to that in 2008?
Ensure brevity in your answer.  1.58. What is the ratio of the Grants(current US$) of Bolivia in 2005 to that in 2009?
Offer a very short reply. 1.56. What is the ratio of the Grants(current US$) in Burkina Faso in 2005 to that in 2009?
Keep it short and to the point. 0.86. What is the ratio of the Grants(current US$) in Cameroon in 2005 to that in 2009?
Your response must be concise. 0.98. What is the ratio of the Grants(current US$) in Marshall Islands in 2005 to that in 2009?
Offer a very short reply. 1.26. What is the ratio of the Grants(current US$) of Bolivia in 2006 to that in 2007?
Your response must be concise. 2.77. What is the ratio of the Grants(current US$) in Burkina Faso in 2006 to that in 2007?
Your answer should be compact. 1.14. What is the ratio of the Grants(current US$) of Cameroon in 2006 to that in 2007?
Provide a succinct answer. 0.91. What is the ratio of the Grants(current US$) in Marshall Islands in 2006 to that in 2007?
Ensure brevity in your answer.  1.03. What is the ratio of the Grants(current US$) of Bolivia in 2006 to that in 2008?
Keep it short and to the point. 2.19. What is the ratio of the Grants(current US$) in Burkina Faso in 2006 to that in 2008?
Provide a succinct answer. 1.31. What is the ratio of the Grants(current US$) in Cameroon in 2006 to that in 2008?
Your answer should be compact. 1.13. What is the ratio of the Grants(current US$) in Marshall Islands in 2006 to that in 2008?
Ensure brevity in your answer.  1.22. What is the ratio of the Grants(current US$) in Bolivia in 2006 to that in 2009?
Your answer should be very brief. 1.97. What is the ratio of the Grants(current US$) of Burkina Faso in 2006 to that in 2009?
Offer a very short reply. 1.14. What is the ratio of the Grants(current US$) in Cameroon in 2006 to that in 2009?
Your response must be concise. 1.17. What is the ratio of the Grants(current US$) in Marshall Islands in 2006 to that in 2009?
Give a very brief answer. 0.97. What is the ratio of the Grants(current US$) in Bolivia in 2007 to that in 2008?
Your answer should be compact. 0.79. What is the ratio of the Grants(current US$) of Burkina Faso in 2007 to that in 2008?
Ensure brevity in your answer.  1.15. What is the ratio of the Grants(current US$) of Cameroon in 2007 to that in 2008?
Keep it short and to the point. 1.24. What is the ratio of the Grants(current US$) in Marshall Islands in 2007 to that in 2008?
Offer a terse response. 1.18. What is the ratio of the Grants(current US$) in Bolivia in 2007 to that in 2009?
Your answer should be very brief. 0.71. What is the ratio of the Grants(current US$) of Burkina Faso in 2007 to that in 2009?
Provide a succinct answer. 1. What is the ratio of the Grants(current US$) in Cameroon in 2007 to that in 2009?
Ensure brevity in your answer.  1.29. What is the ratio of the Grants(current US$) in Marshall Islands in 2007 to that in 2009?
Provide a succinct answer. 0.93. What is the ratio of the Grants(current US$) in Bolivia in 2008 to that in 2009?
Keep it short and to the point. 0.9. What is the ratio of the Grants(current US$) of Burkina Faso in 2008 to that in 2009?
Make the answer very short. 0.87. What is the ratio of the Grants(current US$) in Cameroon in 2008 to that in 2009?
Your answer should be very brief. 1.04. What is the ratio of the Grants(current US$) of Marshall Islands in 2008 to that in 2009?
Give a very brief answer. 0.79. What is the difference between the highest and the second highest Grants(current US$) in Bolivia?
Offer a terse response. 3.74e+07. What is the difference between the highest and the second highest Grants(current US$) of Burkina Faso?
Provide a short and direct response. 1.54e+07. What is the difference between the highest and the second highest Grants(current US$) of Cameroon?
Offer a very short reply. 1.75e+07. What is the difference between the highest and the second highest Grants(current US$) of Marshall Islands?
Keep it short and to the point. 4.70e+05. What is the difference between the highest and the lowest Grants(current US$) of Bolivia?
Make the answer very short. 1.93e+08. What is the difference between the highest and the lowest Grants(current US$) in Burkina Faso?
Offer a terse response. 3.07e+07. What is the difference between the highest and the lowest Grants(current US$) of Cameroon?
Offer a very short reply. 5.85e+07. What is the difference between the highest and the lowest Grants(current US$) in Marshall Islands?
Provide a short and direct response. 1.62e+06. 